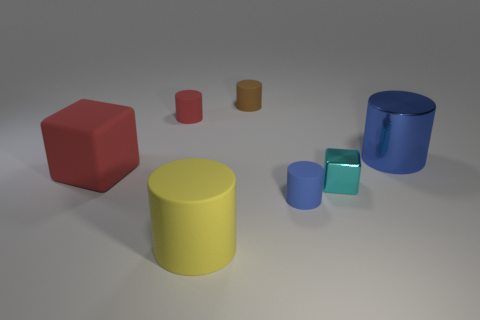What number of tiny red rubber cylinders are to the right of the small red thing that is behind the large rubber block? There is one tiny red rubber cylinder located to the right of the small red object, which is positioned behind the large rubber block. 